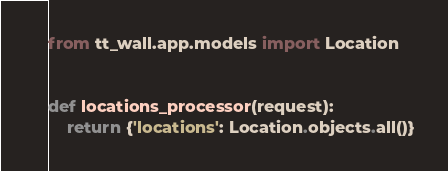<code> <loc_0><loc_0><loc_500><loc_500><_Python_>from tt_wall.app.models import Location


def locations_processor(request):
    return {'locations': Location.objects.all()}
</code> 